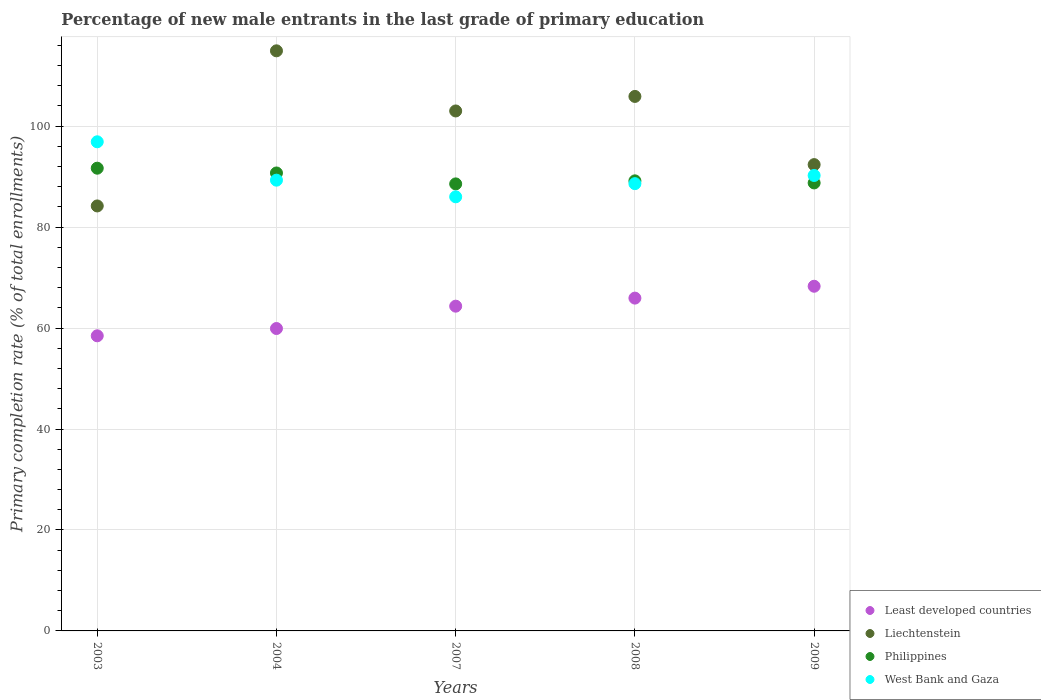How many different coloured dotlines are there?
Ensure brevity in your answer.  4. What is the percentage of new male entrants in Philippines in 2007?
Give a very brief answer. 88.56. Across all years, what is the maximum percentage of new male entrants in Philippines?
Provide a short and direct response. 91.67. Across all years, what is the minimum percentage of new male entrants in West Bank and Gaza?
Ensure brevity in your answer.  86. What is the total percentage of new male entrants in West Bank and Gaza in the graph?
Give a very brief answer. 451.02. What is the difference between the percentage of new male entrants in Least developed countries in 2004 and that in 2007?
Give a very brief answer. -4.43. What is the difference between the percentage of new male entrants in Liechtenstein in 2003 and the percentage of new male entrants in Philippines in 2007?
Give a very brief answer. -4.37. What is the average percentage of new male entrants in Philippines per year?
Give a very brief answer. 89.77. In the year 2009, what is the difference between the percentage of new male entrants in Least developed countries and percentage of new male entrants in Philippines?
Ensure brevity in your answer.  -20.47. What is the ratio of the percentage of new male entrants in West Bank and Gaza in 2007 to that in 2008?
Keep it short and to the point. 0.97. Is the percentage of new male entrants in Philippines in 2004 less than that in 2009?
Offer a very short reply. No. What is the difference between the highest and the second highest percentage of new male entrants in West Bank and Gaza?
Ensure brevity in your answer.  6.67. What is the difference between the highest and the lowest percentage of new male entrants in West Bank and Gaza?
Give a very brief answer. 10.9. In how many years, is the percentage of new male entrants in Philippines greater than the average percentage of new male entrants in Philippines taken over all years?
Your response must be concise. 2. Is the sum of the percentage of new male entrants in Least developed countries in 2004 and 2009 greater than the maximum percentage of new male entrants in Liechtenstein across all years?
Provide a succinct answer. Yes. Is it the case that in every year, the sum of the percentage of new male entrants in Philippines and percentage of new male entrants in West Bank and Gaza  is greater than the sum of percentage of new male entrants in Least developed countries and percentage of new male entrants in Liechtenstein?
Provide a short and direct response. No. Does the percentage of new male entrants in Liechtenstein monotonically increase over the years?
Keep it short and to the point. No. Is the percentage of new male entrants in West Bank and Gaza strictly greater than the percentage of new male entrants in Liechtenstein over the years?
Make the answer very short. No. How many dotlines are there?
Your response must be concise. 4. Does the graph contain any zero values?
Keep it short and to the point. No. Where does the legend appear in the graph?
Keep it short and to the point. Bottom right. How many legend labels are there?
Your answer should be compact. 4. How are the legend labels stacked?
Offer a terse response. Vertical. What is the title of the graph?
Provide a short and direct response. Percentage of new male entrants in the last grade of primary education. What is the label or title of the Y-axis?
Offer a very short reply. Primary completion rate (% of total enrollments). What is the Primary completion rate (% of total enrollments) of Least developed countries in 2003?
Your answer should be compact. 58.46. What is the Primary completion rate (% of total enrollments) in Liechtenstein in 2003?
Keep it short and to the point. 84.19. What is the Primary completion rate (% of total enrollments) of Philippines in 2003?
Provide a succinct answer. 91.67. What is the Primary completion rate (% of total enrollments) of West Bank and Gaza in 2003?
Provide a short and direct response. 96.9. What is the Primary completion rate (% of total enrollments) of Least developed countries in 2004?
Offer a very short reply. 59.91. What is the Primary completion rate (% of total enrollments) of Liechtenstein in 2004?
Make the answer very short. 114.92. What is the Primary completion rate (% of total enrollments) in Philippines in 2004?
Keep it short and to the point. 90.72. What is the Primary completion rate (% of total enrollments) in West Bank and Gaza in 2004?
Ensure brevity in your answer.  89.29. What is the Primary completion rate (% of total enrollments) of Least developed countries in 2007?
Make the answer very short. 64.33. What is the Primary completion rate (% of total enrollments) of Liechtenstein in 2007?
Offer a very short reply. 103. What is the Primary completion rate (% of total enrollments) in Philippines in 2007?
Your response must be concise. 88.56. What is the Primary completion rate (% of total enrollments) of West Bank and Gaza in 2007?
Your answer should be very brief. 86. What is the Primary completion rate (% of total enrollments) in Least developed countries in 2008?
Provide a short and direct response. 65.93. What is the Primary completion rate (% of total enrollments) of Liechtenstein in 2008?
Ensure brevity in your answer.  105.88. What is the Primary completion rate (% of total enrollments) in Philippines in 2008?
Your answer should be very brief. 89.16. What is the Primary completion rate (% of total enrollments) in West Bank and Gaza in 2008?
Your response must be concise. 88.6. What is the Primary completion rate (% of total enrollments) of Least developed countries in 2009?
Offer a terse response. 68.28. What is the Primary completion rate (% of total enrollments) of Liechtenstein in 2009?
Your answer should be compact. 92.38. What is the Primary completion rate (% of total enrollments) of Philippines in 2009?
Offer a terse response. 88.75. What is the Primary completion rate (% of total enrollments) in West Bank and Gaza in 2009?
Your response must be concise. 90.22. Across all years, what is the maximum Primary completion rate (% of total enrollments) of Least developed countries?
Make the answer very short. 68.28. Across all years, what is the maximum Primary completion rate (% of total enrollments) of Liechtenstein?
Provide a short and direct response. 114.92. Across all years, what is the maximum Primary completion rate (% of total enrollments) in Philippines?
Your answer should be very brief. 91.67. Across all years, what is the maximum Primary completion rate (% of total enrollments) in West Bank and Gaza?
Offer a terse response. 96.9. Across all years, what is the minimum Primary completion rate (% of total enrollments) in Least developed countries?
Make the answer very short. 58.46. Across all years, what is the minimum Primary completion rate (% of total enrollments) in Liechtenstein?
Ensure brevity in your answer.  84.19. Across all years, what is the minimum Primary completion rate (% of total enrollments) in Philippines?
Ensure brevity in your answer.  88.56. Across all years, what is the minimum Primary completion rate (% of total enrollments) of West Bank and Gaza?
Offer a very short reply. 86. What is the total Primary completion rate (% of total enrollments) in Least developed countries in the graph?
Offer a terse response. 316.91. What is the total Primary completion rate (% of total enrollments) of Liechtenstein in the graph?
Ensure brevity in your answer.  500.37. What is the total Primary completion rate (% of total enrollments) of Philippines in the graph?
Offer a very short reply. 448.85. What is the total Primary completion rate (% of total enrollments) of West Bank and Gaza in the graph?
Provide a succinct answer. 451.02. What is the difference between the Primary completion rate (% of total enrollments) in Least developed countries in 2003 and that in 2004?
Provide a short and direct response. -1.44. What is the difference between the Primary completion rate (% of total enrollments) of Liechtenstein in 2003 and that in 2004?
Keep it short and to the point. -30.73. What is the difference between the Primary completion rate (% of total enrollments) in Philippines in 2003 and that in 2004?
Keep it short and to the point. 0.95. What is the difference between the Primary completion rate (% of total enrollments) in West Bank and Gaza in 2003 and that in 2004?
Provide a short and direct response. 7.6. What is the difference between the Primary completion rate (% of total enrollments) of Least developed countries in 2003 and that in 2007?
Make the answer very short. -5.87. What is the difference between the Primary completion rate (% of total enrollments) in Liechtenstein in 2003 and that in 2007?
Make the answer very short. -18.82. What is the difference between the Primary completion rate (% of total enrollments) of Philippines in 2003 and that in 2007?
Your answer should be compact. 3.11. What is the difference between the Primary completion rate (% of total enrollments) of West Bank and Gaza in 2003 and that in 2007?
Make the answer very short. 10.9. What is the difference between the Primary completion rate (% of total enrollments) in Least developed countries in 2003 and that in 2008?
Ensure brevity in your answer.  -7.47. What is the difference between the Primary completion rate (% of total enrollments) in Liechtenstein in 2003 and that in 2008?
Your answer should be very brief. -21.69. What is the difference between the Primary completion rate (% of total enrollments) in Philippines in 2003 and that in 2008?
Your answer should be compact. 2.51. What is the difference between the Primary completion rate (% of total enrollments) in West Bank and Gaza in 2003 and that in 2008?
Make the answer very short. 8.29. What is the difference between the Primary completion rate (% of total enrollments) of Least developed countries in 2003 and that in 2009?
Your answer should be very brief. -9.82. What is the difference between the Primary completion rate (% of total enrollments) of Liechtenstein in 2003 and that in 2009?
Ensure brevity in your answer.  -8.19. What is the difference between the Primary completion rate (% of total enrollments) of Philippines in 2003 and that in 2009?
Provide a succinct answer. 2.92. What is the difference between the Primary completion rate (% of total enrollments) of West Bank and Gaza in 2003 and that in 2009?
Ensure brevity in your answer.  6.67. What is the difference between the Primary completion rate (% of total enrollments) of Least developed countries in 2004 and that in 2007?
Provide a short and direct response. -4.43. What is the difference between the Primary completion rate (% of total enrollments) in Liechtenstein in 2004 and that in 2007?
Provide a short and direct response. 11.91. What is the difference between the Primary completion rate (% of total enrollments) of Philippines in 2004 and that in 2007?
Keep it short and to the point. 2.16. What is the difference between the Primary completion rate (% of total enrollments) of West Bank and Gaza in 2004 and that in 2007?
Keep it short and to the point. 3.3. What is the difference between the Primary completion rate (% of total enrollments) of Least developed countries in 2004 and that in 2008?
Provide a short and direct response. -6.02. What is the difference between the Primary completion rate (% of total enrollments) in Liechtenstein in 2004 and that in 2008?
Your response must be concise. 9.03. What is the difference between the Primary completion rate (% of total enrollments) in Philippines in 2004 and that in 2008?
Provide a succinct answer. 1.56. What is the difference between the Primary completion rate (% of total enrollments) of West Bank and Gaza in 2004 and that in 2008?
Provide a short and direct response. 0.69. What is the difference between the Primary completion rate (% of total enrollments) of Least developed countries in 2004 and that in 2009?
Offer a very short reply. -8.37. What is the difference between the Primary completion rate (% of total enrollments) of Liechtenstein in 2004 and that in 2009?
Your answer should be compact. 22.54. What is the difference between the Primary completion rate (% of total enrollments) of Philippines in 2004 and that in 2009?
Keep it short and to the point. 1.97. What is the difference between the Primary completion rate (% of total enrollments) in West Bank and Gaza in 2004 and that in 2009?
Offer a very short reply. -0.93. What is the difference between the Primary completion rate (% of total enrollments) in Least developed countries in 2007 and that in 2008?
Ensure brevity in your answer.  -1.6. What is the difference between the Primary completion rate (% of total enrollments) in Liechtenstein in 2007 and that in 2008?
Provide a short and direct response. -2.88. What is the difference between the Primary completion rate (% of total enrollments) in Philippines in 2007 and that in 2008?
Offer a very short reply. -0.6. What is the difference between the Primary completion rate (% of total enrollments) in West Bank and Gaza in 2007 and that in 2008?
Your response must be concise. -2.61. What is the difference between the Primary completion rate (% of total enrollments) of Least developed countries in 2007 and that in 2009?
Provide a succinct answer. -3.95. What is the difference between the Primary completion rate (% of total enrollments) of Liechtenstein in 2007 and that in 2009?
Give a very brief answer. 10.63. What is the difference between the Primary completion rate (% of total enrollments) in Philippines in 2007 and that in 2009?
Offer a very short reply. -0.19. What is the difference between the Primary completion rate (% of total enrollments) of West Bank and Gaza in 2007 and that in 2009?
Make the answer very short. -4.23. What is the difference between the Primary completion rate (% of total enrollments) in Least developed countries in 2008 and that in 2009?
Ensure brevity in your answer.  -2.35. What is the difference between the Primary completion rate (% of total enrollments) of Liechtenstein in 2008 and that in 2009?
Your answer should be very brief. 13.51. What is the difference between the Primary completion rate (% of total enrollments) of Philippines in 2008 and that in 2009?
Offer a very short reply. 0.41. What is the difference between the Primary completion rate (% of total enrollments) in West Bank and Gaza in 2008 and that in 2009?
Your response must be concise. -1.62. What is the difference between the Primary completion rate (% of total enrollments) in Least developed countries in 2003 and the Primary completion rate (% of total enrollments) in Liechtenstein in 2004?
Offer a very short reply. -56.46. What is the difference between the Primary completion rate (% of total enrollments) in Least developed countries in 2003 and the Primary completion rate (% of total enrollments) in Philippines in 2004?
Make the answer very short. -32.26. What is the difference between the Primary completion rate (% of total enrollments) in Least developed countries in 2003 and the Primary completion rate (% of total enrollments) in West Bank and Gaza in 2004?
Offer a very short reply. -30.83. What is the difference between the Primary completion rate (% of total enrollments) in Liechtenstein in 2003 and the Primary completion rate (% of total enrollments) in Philippines in 2004?
Provide a short and direct response. -6.53. What is the difference between the Primary completion rate (% of total enrollments) in Liechtenstein in 2003 and the Primary completion rate (% of total enrollments) in West Bank and Gaza in 2004?
Your answer should be very brief. -5.11. What is the difference between the Primary completion rate (% of total enrollments) in Philippines in 2003 and the Primary completion rate (% of total enrollments) in West Bank and Gaza in 2004?
Offer a very short reply. 2.37. What is the difference between the Primary completion rate (% of total enrollments) in Least developed countries in 2003 and the Primary completion rate (% of total enrollments) in Liechtenstein in 2007?
Provide a succinct answer. -44.54. What is the difference between the Primary completion rate (% of total enrollments) in Least developed countries in 2003 and the Primary completion rate (% of total enrollments) in Philippines in 2007?
Offer a very short reply. -30.09. What is the difference between the Primary completion rate (% of total enrollments) in Least developed countries in 2003 and the Primary completion rate (% of total enrollments) in West Bank and Gaza in 2007?
Offer a terse response. -27.54. What is the difference between the Primary completion rate (% of total enrollments) of Liechtenstein in 2003 and the Primary completion rate (% of total enrollments) of Philippines in 2007?
Make the answer very short. -4.37. What is the difference between the Primary completion rate (% of total enrollments) of Liechtenstein in 2003 and the Primary completion rate (% of total enrollments) of West Bank and Gaza in 2007?
Your answer should be compact. -1.81. What is the difference between the Primary completion rate (% of total enrollments) in Philippines in 2003 and the Primary completion rate (% of total enrollments) in West Bank and Gaza in 2007?
Your answer should be very brief. 5.67. What is the difference between the Primary completion rate (% of total enrollments) of Least developed countries in 2003 and the Primary completion rate (% of total enrollments) of Liechtenstein in 2008?
Offer a very short reply. -47.42. What is the difference between the Primary completion rate (% of total enrollments) of Least developed countries in 2003 and the Primary completion rate (% of total enrollments) of Philippines in 2008?
Your answer should be very brief. -30.7. What is the difference between the Primary completion rate (% of total enrollments) of Least developed countries in 2003 and the Primary completion rate (% of total enrollments) of West Bank and Gaza in 2008?
Keep it short and to the point. -30.14. What is the difference between the Primary completion rate (% of total enrollments) in Liechtenstein in 2003 and the Primary completion rate (% of total enrollments) in Philippines in 2008?
Your response must be concise. -4.97. What is the difference between the Primary completion rate (% of total enrollments) of Liechtenstein in 2003 and the Primary completion rate (% of total enrollments) of West Bank and Gaza in 2008?
Your response must be concise. -4.42. What is the difference between the Primary completion rate (% of total enrollments) in Philippines in 2003 and the Primary completion rate (% of total enrollments) in West Bank and Gaza in 2008?
Your response must be concise. 3.06. What is the difference between the Primary completion rate (% of total enrollments) in Least developed countries in 2003 and the Primary completion rate (% of total enrollments) in Liechtenstein in 2009?
Offer a very short reply. -33.91. What is the difference between the Primary completion rate (% of total enrollments) in Least developed countries in 2003 and the Primary completion rate (% of total enrollments) in Philippines in 2009?
Your response must be concise. -30.29. What is the difference between the Primary completion rate (% of total enrollments) in Least developed countries in 2003 and the Primary completion rate (% of total enrollments) in West Bank and Gaza in 2009?
Give a very brief answer. -31.76. What is the difference between the Primary completion rate (% of total enrollments) of Liechtenstein in 2003 and the Primary completion rate (% of total enrollments) of Philippines in 2009?
Ensure brevity in your answer.  -4.56. What is the difference between the Primary completion rate (% of total enrollments) in Liechtenstein in 2003 and the Primary completion rate (% of total enrollments) in West Bank and Gaza in 2009?
Your answer should be very brief. -6.04. What is the difference between the Primary completion rate (% of total enrollments) of Philippines in 2003 and the Primary completion rate (% of total enrollments) of West Bank and Gaza in 2009?
Your answer should be very brief. 1.44. What is the difference between the Primary completion rate (% of total enrollments) in Least developed countries in 2004 and the Primary completion rate (% of total enrollments) in Liechtenstein in 2007?
Give a very brief answer. -43.1. What is the difference between the Primary completion rate (% of total enrollments) in Least developed countries in 2004 and the Primary completion rate (% of total enrollments) in Philippines in 2007?
Offer a very short reply. -28.65. What is the difference between the Primary completion rate (% of total enrollments) in Least developed countries in 2004 and the Primary completion rate (% of total enrollments) in West Bank and Gaza in 2007?
Your answer should be compact. -26.09. What is the difference between the Primary completion rate (% of total enrollments) of Liechtenstein in 2004 and the Primary completion rate (% of total enrollments) of Philippines in 2007?
Make the answer very short. 26.36. What is the difference between the Primary completion rate (% of total enrollments) of Liechtenstein in 2004 and the Primary completion rate (% of total enrollments) of West Bank and Gaza in 2007?
Your answer should be very brief. 28.92. What is the difference between the Primary completion rate (% of total enrollments) in Philippines in 2004 and the Primary completion rate (% of total enrollments) in West Bank and Gaza in 2007?
Your answer should be very brief. 4.72. What is the difference between the Primary completion rate (% of total enrollments) in Least developed countries in 2004 and the Primary completion rate (% of total enrollments) in Liechtenstein in 2008?
Provide a succinct answer. -45.98. What is the difference between the Primary completion rate (% of total enrollments) of Least developed countries in 2004 and the Primary completion rate (% of total enrollments) of Philippines in 2008?
Ensure brevity in your answer.  -29.25. What is the difference between the Primary completion rate (% of total enrollments) of Least developed countries in 2004 and the Primary completion rate (% of total enrollments) of West Bank and Gaza in 2008?
Your answer should be very brief. -28.7. What is the difference between the Primary completion rate (% of total enrollments) of Liechtenstein in 2004 and the Primary completion rate (% of total enrollments) of Philippines in 2008?
Make the answer very short. 25.76. What is the difference between the Primary completion rate (% of total enrollments) in Liechtenstein in 2004 and the Primary completion rate (% of total enrollments) in West Bank and Gaza in 2008?
Your response must be concise. 26.31. What is the difference between the Primary completion rate (% of total enrollments) in Philippines in 2004 and the Primary completion rate (% of total enrollments) in West Bank and Gaza in 2008?
Your answer should be compact. 2.12. What is the difference between the Primary completion rate (% of total enrollments) in Least developed countries in 2004 and the Primary completion rate (% of total enrollments) in Liechtenstein in 2009?
Your answer should be compact. -32.47. What is the difference between the Primary completion rate (% of total enrollments) in Least developed countries in 2004 and the Primary completion rate (% of total enrollments) in Philippines in 2009?
Make the answer very short. -28.84. What is the difference between the Primary completion rate (% of total enrollments) in Least developed countries in 2004 and the Primary completion rate (% of total enrollments) in West Bank and Gaza in 2009?
Offer a terse response. -30.32. What is the difference between the Primary completion rate (% of total enrollments) in Liechtenstein in 2004 and the Primary completion rate (% of total enrollments) in Philippines in 2009?
Give a very brief answer. 26.17. What is the difference between the Primary completion rate (% of total enrollments) of Liechtenstein in 2004 and the Primary completion rate (% of total enrollments) of West Bank and Gaza in 2009?
Offer a terse response. 24.69. What is the difference between the Primary completion rate (% of total enrollments) of Philippines in 2004 and the Primary completion rate (% of total enrollments) of West Bank and Gaza in 2009?
Ensure brevity in your answer.  0.5. What is the difference between the Primary completion rate (% of total enrollments) of Least developed countries in 2007 and the Primary completion rate (% of total enrollments) of Liechtenstein in 2008?
Your answer should be compact. -41.55. What is the difference between the Primary completion rate (% of total enrollments) of Least developed countries in 2007 and the Primary completion rate (% of total enrollments) of Philippines in 2008?
Ensure brevity in your answer.  -24.83. What is the difference between the Primary completion rate (% of total enrollments) in Least developed countries in 2007 and the Primary completion rate (% of total enrollments) in West Bank and Gaza in 2008?
Your answer should be very brief. -24.27. What is the difference between the Primary completion rate (% of total enrollments) in Liechtenstein in 2007 and the Primary completion rate (% of total enrollments) in Philippines in 2008?
Offer a terse response. 13.85. What is the difference between the Primary completion rate (% of total enrollments) of Liechtenstein in 2007 and the Primary completion rate (% of total enrollments) of West Bank and Gaza in 2008?
Provide a short and direct response. 14.4. What is the difference between the Primary completion rate (% of total enrollments) in Philippines in 2007 and the Primary completion rate (% of total enrollments) in West Bank and Gaza in 2008?
Provide a short and direct response. -0.05. What is the difference between the Primary completion rate (% of total enrollments) in Least developed countries in 2007 and the Primary completion rate (% of total enrollments) in Liechtenstein in 2009?
Ensure brevity in your answer.  -28.04. What is the difference between the Primary completion rate (% of total enrollments) in Least developed countries in 2007 and the Primary completion rate (% of total enrollments) in Philippines in 2009?
Your response must be concise. -24.41. What is the difference between the Primary completion rate (% of total enrollments) in Least developed countries in 2007 and the Primary completion rate (% of total enrollments) in West Bank and Gaza in 2009?
Keep it short and to the point. -25.89. What is the difference between the Primary completion rate (% of total enrollments) in Liechtenstein in 2007 and the Primary completion rate (% of total enrollments) in Philippines in 2009?
Ensure brevity in your answer.  14.26. What is the difference between the Primary completion rate (% of total enrollments) of Liechtenstein in 2007 and the Primary completion rate (% of total enrollments) of West Bank and Gaza in 2009?
Offer a very short reply. 12.78. What is the difference between the Primary completion rate (% of total enrollments) of Philippines in 2007 and the Primary completion rate (% of total enrollments) of West Bank and Gaza in 2009?
Offer a very short reply. -1.67. What is the difference between the Primary completion rate (% of total enrollments) of Least developed countries in 2008 and the Primary completion rate (% of total enrollments) of Liechtenstein in 2009?
Ensure brevity in your answer.  -26.45. What is the difference between the Primary completion rate (% of total enrollments) of Least developed countries in 2008 and the Primary completion rate (% of total enrollments) of Philippines in 2009?
Your answer should be very brief. -22.82. What is the difference between the Primary completion rate (% of total enrollments) of Least developed countries in 2008 and the Primary completion rate (% of total enrollments) of West Bank and Gaza in 2009?
Offer a terse response. -24.29. What is the difference between the Primary completion rate (% of total enrollments) in Liechtenstein in 2008 and the Primary completion rate (% of total enrollments) in Philippines in 2009?
Provide a succinct answer. 17.14. What is the difference between the Primary completion rate (% of total enrollments) in Liechtenstein in 2008 and the Primary completion rate (% of total enrollments) in West Bank and Gaza in 2009?
Keep it short and to the point. 15.66. What is the difference between the Primary completion rate (% of total enrollments) in Philippines in 2008 and the Primary completion rate (% of total enrollments) in West Bank and Gaza in 2009?
Your response must be concise. -1.06. What is the average Primary completion rate (% of total enrollments) of Least developed countries per year?
Provide a short and direct response. 63.38. What is the average Primary completion rate (% of total enrollments) in Liechtenstein per year?
Your answer should be compact. 100.07. What is the average Primary completion rate (% of total enrollments) in Philippines per year?
Provide a succinct answer. 89.77. What is the average Primary completion rate (% of total enrollments) of West Bank and Gaza per year?
Make the answer very short. 90.2. In the year 2003, what is the difference between the Primary completion rate (% of total enrollments) in Least developed countries and Primary completion rate (% of total enrollments) in Liechtenstein?
Your response must be concise. -25.73. In the year 2003, what is the difference between the Primary completion rate (% of total enrollments) in Least developed countries and Primary completion rate (% of total enrollments) in Philippines?
Make the answer very short. -33.2. In the year 2003, what is the difference between the Primary completion rate (% of total enrollments) of Least developed countries and Primary completion rate (% of total enrollments) of West Bank and Gaza?
Your response must be concise. -38.43. In the year 2003, what is the difference between the Primary completion rate (% of total enrollments) of Liechtenstein and Primary completion rate (% of total enrollments) of Philippines?
Ensure brevity in your answer.  -7.48. In the year 2003, what is the difference between the Primary completion rate (% of total enrollments) of Liechtenstein and Primary completion rate (% of total enrollments) of West Bank and Gaza?
Your response must be concise. -12.71. In the year 2003, what is the difference between the Primary completion rate (% of total enrollments) in Philippines and Primary completion rate (% of total enrollments) in West Bank and Gaza?
Your answer should be compact. -5.23. In the year 2004, what is the difference between the Primary completion rate (% of total enrollments) of Least developed countries and Primary completion rate (% of total enrollments) of Liechtenstein?
Your response must be concise. -55.01. In the year 2004, what is the difference between the Primary completion rate (% of total enrollments) of Least developed countries and Primary completion rate (% of total enrollments) of Philippines?
Your answer should be very brief. -30.81. In the year 2004, what is the difference between the Primary completion rate (% of total enrollments) in Least developed countries and Primary completion rate (% of total enrollments) in West Bank and Gaza?
Provide a succinct answer. -29.39. In the year 2004, what is the difference between the Primary completion rate (% of total enrollments) in Liechtenstein and Primary completion rate (% of total enrollments) in Philippines?
Your response must be concise. 24.2. In the year 2004, what is the difference between the Primary completion rate (% of total enrollments) of Liechtenstein and Primary completion rate (% of total enrollments) of West Bank and Gaza?
Give a very brief answer. 25.62. In the year 2004, what is the difference between the Primary completion rate (% of total enrollments) in Philippines and Primary completion rate (% of total enrollments) in West Bank and Gaza?
Your answer should be compact. 1.43. In the year 2007, what is the difference between the Primary completion rate (% of total enrollments) of Least developed countries and Primary completion rate (% of total enrollments) of Liechtenstein?
Your response must be concise. -38.67. In the year 2007, what is the difference between the Primary completion rate (% of total enrollments) in Least developed countries and Primary completion rate (% of total enrollments) in Philippines?
Offer a very short reply. -24.22. In the year 2007, what is the difference between the Primary completion rate (% of total enrollments) of Least developed countries and Primary completion rate (% of total enrollments) of West Bank and Gaza?
Offer a very short reply. -21.66. In the year 2007, what is the difference between the Primary completion rate (% of total enrollments) of Liechtenstein and Primary completion rate (% of total enrollments) of Philippines?
Your answer should be very brief. 14.45. In the year 2007, what is the difference between the Primary completion rate (% of total enrollments) in Liechtenstein and Primary completion rate (% of total enrollments) in West Bank and Gaza?
Your answer should be very brief. 17.01. In the year 2007, what is the difference between the Primary completion rate (% of total enrollments) in Philippines and Primary completion rate (% of total enrollments) in West Bank and Gaza?
Your response must be concise. 2.56. In the year 2008, what is the difference between the Primary completion rate (% of total enrollments) in Least developed countries and Primary completion rate (% of total enrollments) in Liechtenstein?
Give a very brief answer. -39.95. In the year 2008, what is the difference between the Primary completion rate (% of total enrollments) of Least developed countries and Primary completion rate (% of total enrollments) of Philippines?
Ensure brevity in your answer.  -23.23. In the year 2008, what is the difference between the Primary completion rate (% of total enrollments) in Least developed countries and Primary completion rate (% of total enrollments) in West Bank and Gaza?
Provide a short and direct response. -22.67. In the year 2008, what is the difference between the Primary completion rate (% of total enrollments) of Liechtenstein and Primary completion rate (% of total enrollments) of Philippines?
Offer a very short reply. 16.72. In the year 2008, what is the difference between the Primary completion rate (% of total enrollments) in Liechtenstein and Primary completion rate (% of total enrollments) in West Bank and Gaza?
Keep it short and to the point. 17.28. In the year 2008, what is the difference between the Primary completion rate (% of total enrollments) in Philippines and Primary completion rate (% of total enrollments) in West Bank and Gaza?
Ensure brevity in your answer.  0.55. In the year 2009, what is the difference between the Primary completion rate (% of total enrollments) in Least developed countries and Primary completion rate (% of total enrollments) in Liechtenstein?
Ensure brevity in your answer.  -24.1. In the year 2009, what is the difference between the Primary completion rate (% of total enrollments) in Least developed countries and Primary completion rate (% of total enrollments) in Philippines?
Give a very brief answer. -20.47. In the year 2009, what is the difference between the Primary completion rate (% of total enrollments) in Least developed countries and Primary completion rate (% of total enrollments) in West Bank and Gaza?
Make the answer very short. -21.94. In the year 2009, what is the difference between the Primary completion rate (% of total enrollments) in Liechtenstein and Primary completion rate (% of total enrollments) in Philippines?
Your answer should be compact. 3.63. In the year 2009, what is the difference between the Primary completion rate (% of total enrollments) in Liechtenstein and Primary completion rate (% of total enrollments) in West Bank and Gaza?
Make the answer very short. 2.15. In the year 2009, what is the difference between the Primary completion rate (% of total enrollments) of Philippines and Primary completion rate (% of total enrollments) of West Bank and Gaza?
Offer a terse response. -1.48. What is the ratio of the Primary completion rate (% of total enrollments) of Least developed countries in 2003 to that in 2004?
Your answer should be compact. 0.98. What is the ratio of the Primary completion rate (% of total enrollments) of Liechtenstein in 2003 to that in 2004?
Ensure brevity in your answer.  0.73. What is the ratio of the Primary completion rate (% of total enrollments) of Philippines in 2003 to that in 2004?
Your answer should be compact. 1.01. What is the ratio of the Primary completion rate (% of total enrollments) of West Bank and Gaza in 2003 to that in 2004?
Ensure brevity in your answer.  1.09. What is the ratio of the Primary completion rate (% of total enrollments) in Least developed countries in 2003 to that in 2007?
Ensure brevity in your answer.  0.91. What is the ratio of the Primary completion rate (% of total enrollments) of Liechtenstein in 2003 to that in 2007?
Provide a succinct answer. 0.82. What is the ratio of the Primary completion rate (% of total enrollments) in Philippines in 2003 to that in 2007?
Offer a very short reply. 1.04. What is the ratio of the Primary completion rate (% of total enrollments) of West Bank and Gaza in 2003 to that in 2007?
Provide a short and direct response. 1.13. What is the ratio of the Primary completion rate (% of total enrollments) of Least developed countries in 2003 to that in 2008?
Provide a succinct answer. 0.89. What is the ratio of the Primary completion rate (% of total enrollments) of Liechtenstein in 2003 to that in 2008?
Keep it short and to the point. 0.8. What is the ratio of the Primary completion rate (% of total enrollments) in Philippines in 2003 to that in 2008?
Offer a very short reply. 1.03. What is the ratio of the Primary completion rate (% of total enrollments) of West Bank and Gaza in 2003 to that in 2008?
Make the answer very short. 1.09. What is the ratio of the Primary completion rate (% of total enrollments) of Least developed countries in 2003 to that in 2009?
Ensure brevity in your answer.  0.86. What is the ratio of the Primary completion rate (% of total enrollments) in Liechtenstein in 2003 to that in 2009?
Ensure brevity in your answer.  0.91. What is the ratio of the Primary completion rate (% of total enrollments) of Philippines in 2003 to that in 2009?
Your response must be concise. 1.03. What is the ratio of the Primary completion rate (% of total enrollments) in West Bank and Gaza in 2003 to that in 2009?
Your answer should be compact. 1.07. What is the ratio of the Primary completion rate (% of total enrollments) of Least developed countries in 2004 to that in 2007?
Provide a succinct answer. 0.93. What is the ratio of the Primary completion rate (% of total enrollments) of Liechtenstein in 2004 to that in 2007?
Keep it short and to the point. 1.12. What is the ratio of the Primary completion rate (% of total enrollments) in Philippines in 2004 to that in 2007?
Your answer should be compact. 1.02. What is the ratio of the Primary completion rate (% of total enrollments) of West Bank and Gaza in 2004 to that in 2007?
Make the answer very short. 1.04. What is the ratio of the Primary completion rate (% of total enrollments) of Least developed countries in 2004 to that in 2008?
Give a very brief answer. 0.91. What is the ratio of the Primary completion rate (% of total enrollments) in Liechtenstein in 2004 to that in 2008?
Your response must be concise. 1.09. What is the ratio of the Primary completion rate (% of total enrollments) in Philippines in 2004 to that in 2008?
Give a very brief answer. 1.02. What is the ratio of the Primary completion rate (% of total enrollments) in West Bank and Gaza in 2004 to that in 2008?
Your answer should be very brief. 1.01. What is the ratio of the Primary completion rate (% of total enrollments) of Least developed countries in 2004 to that in 2009?
Offer a very short reply. 0.88. What is the ratio of the Primary completion rate (% of total enrollments) in Liechtenstein in 2004 to that in 2009?
Give a very brief answer. 1.24. What is the ratio of the Primary completion rate (% of total enrollments) in Philippines in 2004 to that in 2009?
Your answer should be compact. 1.02. What is the ratio of the Primary completion rate (% of total enrollments) of West Bank and Gaza in 2004 to that in 2009?
Keep it short and to the point. 0.99. What is the ratio of the Primary completion rate (% of total enrollments) in Least developed countries in 2007 to that in 2008?
Provide a succinct answer. 0.98. What is the ratio of the Primary completion rate (% of total enrollments) in Liechtenstein in 2007 to that in 2008?
Provide a short and direct response. 0.97. What is the ratio of the Primary completion rate (% of total enrollments) in Philippines in 2007 to that in 2008?
Ensure brevity in your answer.  0.99. What is the ratio of the Primary completion rate (% of total enrollments) of West Bank and Gaza in 2007 to that in 2008?
Ensure brevity in your answer.  0.97. What is the ratio of the Primary completion rate (% of total enrollments) of Least developed countries in 2007 to that in 2009?
Your response must be concise. 0.94. What is the ratio of the Primary completion rate (% of total enrollments) of Liechtenstein in 2007 to that in 2009?
Your answer should be compact. 1.11. What is the ratio of the Primary completion rate (% of total enrollments) of Philippines in 2007 to that in 2009?
Offer a terse response. 1. What is the ratio of the Primary completion rate (% of total enrollments) in West Bank and Gaza in 2007 to that in 2009?
Your answer should be very brief. 0.95. What is the ratio of the Primary completion rate (% of total enrollments) of Least developed countries in 2008 to that in 2009?
Offer a very short reply. 0.97. What is the ratio of the Primary completion rate (% of total enrollments) of Liechtenstein in 2008 to that in 2009?
Ensure brevity in your answer.  1.15. What is the ratio of the Primary completion rate (% of total enrollments) of Philippines in 2008 to that in 2009?
Your response must be concise. 1. What is the ratio of the Primary completion rate (% of total enrollments) in West Bank and Gaza in 2008 to that in 2009?
Provide a succinct answer. 0.98. What is the difference between the highest and the second highest Primary completion rate (% of total enrollments) in Least developed countries?
Provide a succinct answer. 2.35. What is the difference between the highest and the second highest Primary completion rate (% of total enrollments) in Liechtenstein?
Your answer should be compact. 9.03. What is the difference between the highest and the second highest Primary completion rate (% of total enrollments) in Philippines?
Make the answer very short. 0.95. What is the difference between the highest and the second highest Primary completion rate (% of total enrollments) in West Bank and Gaza?
Your answer should be very brief. 6.67. What is the difference between the highest and the lowest Primary completion rate (% of total enrollments) in Least developed countries?
Provide a short and direct response. 9.82. What is the difference between the highest and the lowest Primary completion rate (% of total enrollments) in Liechtenstein?
Provide a succinct answer. 30.73. What is the difference between the highest and the lowest Primary completion rate (% of total enrollments) of Philippines?
Keep it short and to the point. 3.11. What is the difference between the highest and the lowest Primary completion rate (% of total enrollments) in West Bank and Gaza?
Make the answer very short. 10.9. 